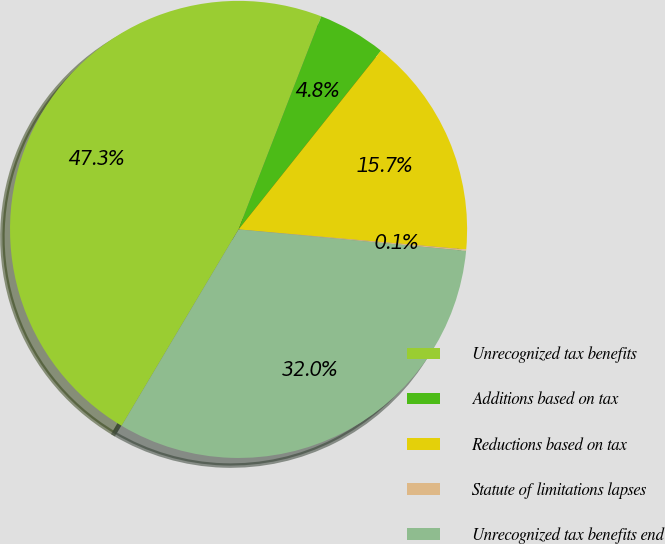<chart> <loc_0><loc_0><loc_500><loc_500><pie_chart><fcel>Unrecognized tax benefits<fcel>Additions based on tax<fcel>Reductions based on tax<fcel>Statute of limitations lapses<fcel>Unrecognized tax benefits end<nl><fcel>47.35%<fcel>4.82%<fcel>15.69%<fcel>0.1%<fcel>32.05%<nl></chart> 